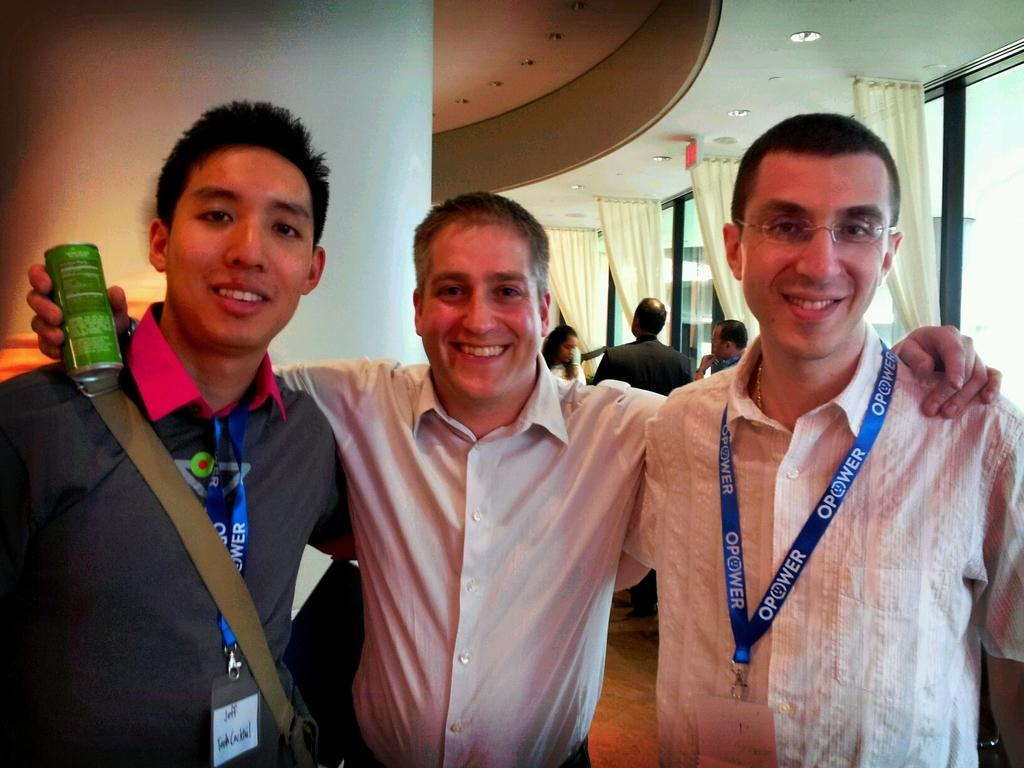<image>
Offer a succinct explanation of the picture presented. Three men post for a photo with event lanyards that say Opower. 